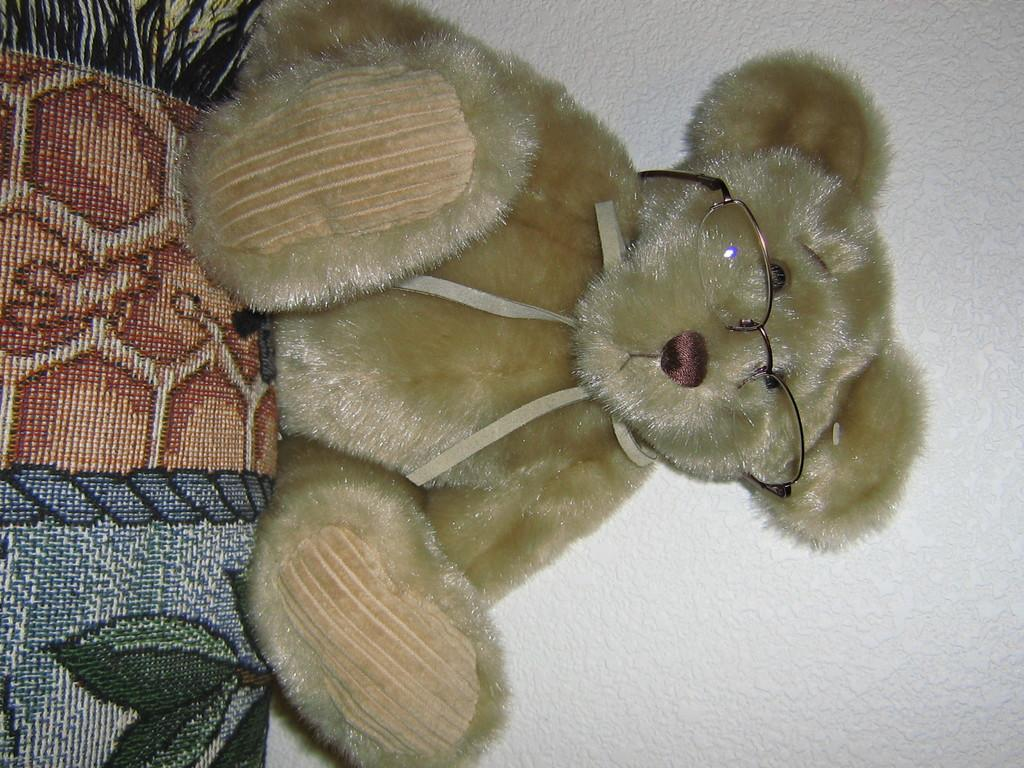What object can be seen in the image? There is a toy in the image. What feature does the toy have? The toy is wearing spectacles. What type of object is truncated towards the left of the image? There is a cloth truncated towards the left of the image. What type of object is truncated in the background of the image? There is a wall truncated in the background of the image. How many quarters are visible in the image? There are no quarters present in the image. What type of recess can be seen in the image? There is no recess present in the image. 